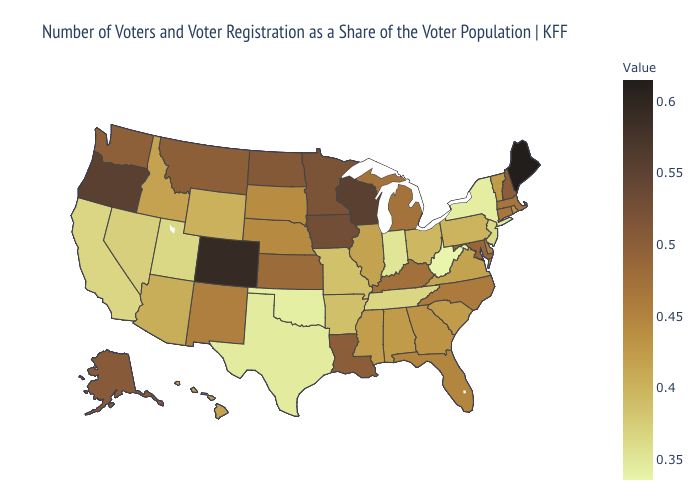Which states have the highest value in the USA?
Short answer required. Maine. Which states have the lowest value in the South?
Give a very brief answer. West Virginia. Does West Virginia have the lowest value in the South?
Concise answer only. Yes. Does Pennsylvania have a lower value than Maine?
Concise answer only. Yes. Which states have the lowest value in the USA?
Write a very short answer. West Virginia. Does Maryland have a higher value than Wisconsin?
Concise answer only. No. Which states have the lowest value in the MidWest?
Write a very short answer. Indiana. Does Texas have a higher value than Alaska?
Concise answer only. No. Is the legend a continuous bar?
Give a very brief answer. Yes. Does Virginia have the highest value in the South?
Be succinct. No. 